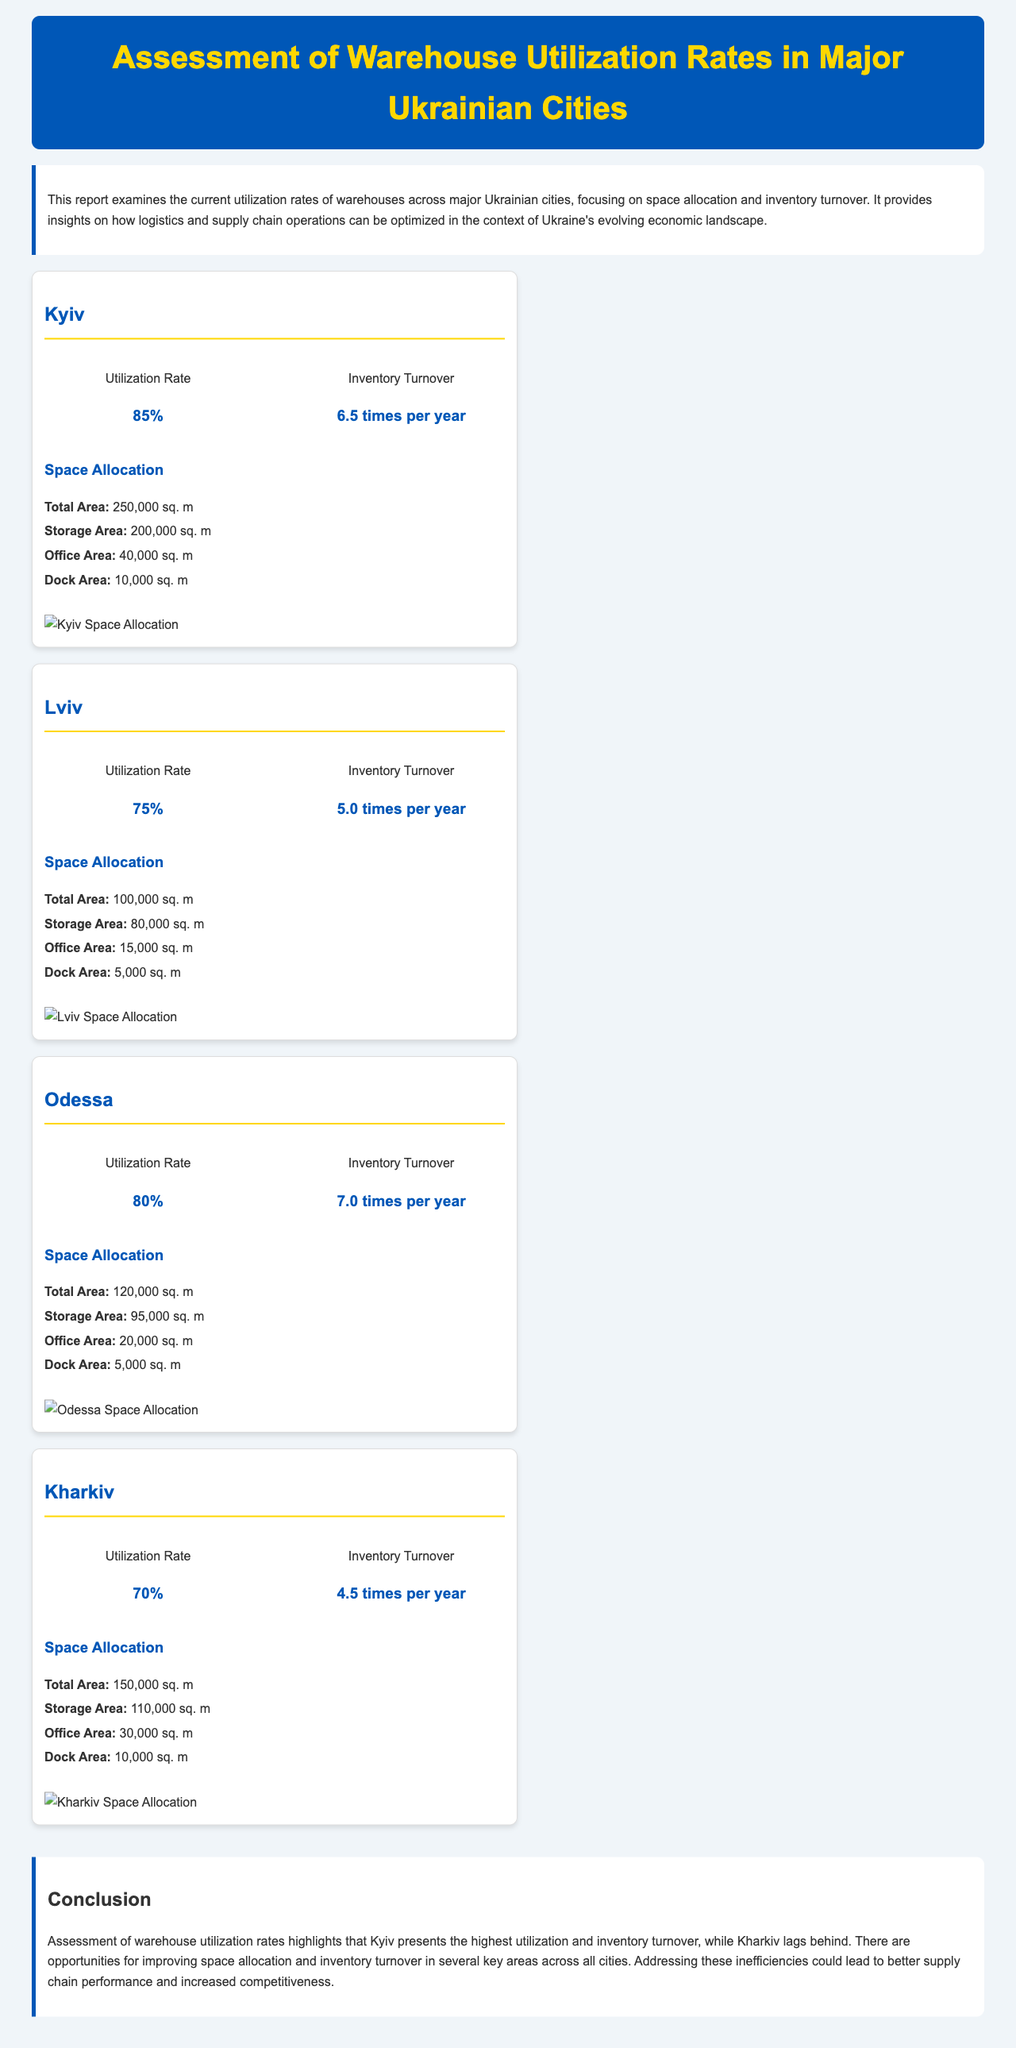What is the utilization rate of Kyiv? The utilization rate for Kyiv is explicitly stated in the document.
Answer: 85% What city has the highest inventory turnover? The document provides a comparison of inventory turnover for each city, indicating which one is the highest.
Answer: Kyiv What is the total area of the warehouse in Lviv? The document lists the total area for Lviv's warehouse under the Space Allocation section.
Answer: 100,000 sq. m Which city has the lowest utilization rate? By comparing the utilization rates listed in the document, it can be deduced which city has the lowest rate.
Answer: Kharkiv What is the dock area in Odessa? The document specifies the dock area for Odessa within the Space Allocation details.
Answer: 5,000 sq. m How many times per year does Odessa's inventory turnover? The inventory turnover for Odessa is provided directly in the statistics section for the city.
Answer: 7.0 times per year What is the total storage area in Kyiv? The document specifies the storage area for Kyiv in the Space Allocation section.
Answer: 200,000 sq. m Which city has a higher utilization rate, Lviv or Kharkiv? A direct comparison of Lviv's and Kharkiv's utilization rates helps answer this question easily.
Answer: Lviv 